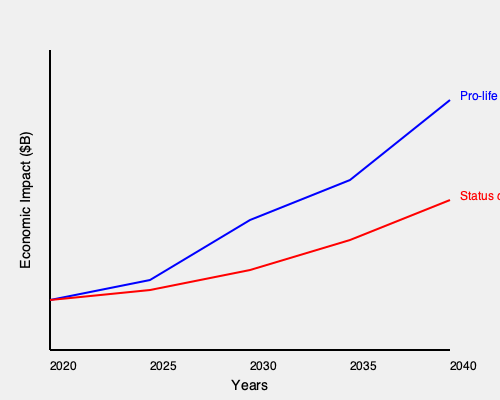Based on the graph, which shows the projected economic impact of pro-life policies compared to the status quo, what is the estimated difference in economic impact between the two scenarios by 2040? To determine the difference in economic impact between pro-life policies and the status quo by 2040, we need to follow these steps:

1. Identify the values for both scenarios in 2040 (rightmost point on the graph):
   - Pro-life policies: approximately $250 billion
   - Status quo: approximately $100 billion

2. Calculate the difference:
   $250 billion - $100 billion = $150 billion

3. Interpret the result:
   The difference of $150 billion represents the additional positive economic impact of pro-life policies compared to maintaining the status quo by 2040.

This difference can be attributed to various factors such as:
- Increased workforce due to higher birth rates
- Reduced healthcare costs associated with abortion-related complications
- Potential growth in adoption and foster care services
- Expansion of family-oriented businesses and services

It's important to note that this graph represents a projection and actual results may vary based on numerous economic and social factors.
Answer: $150 billion 